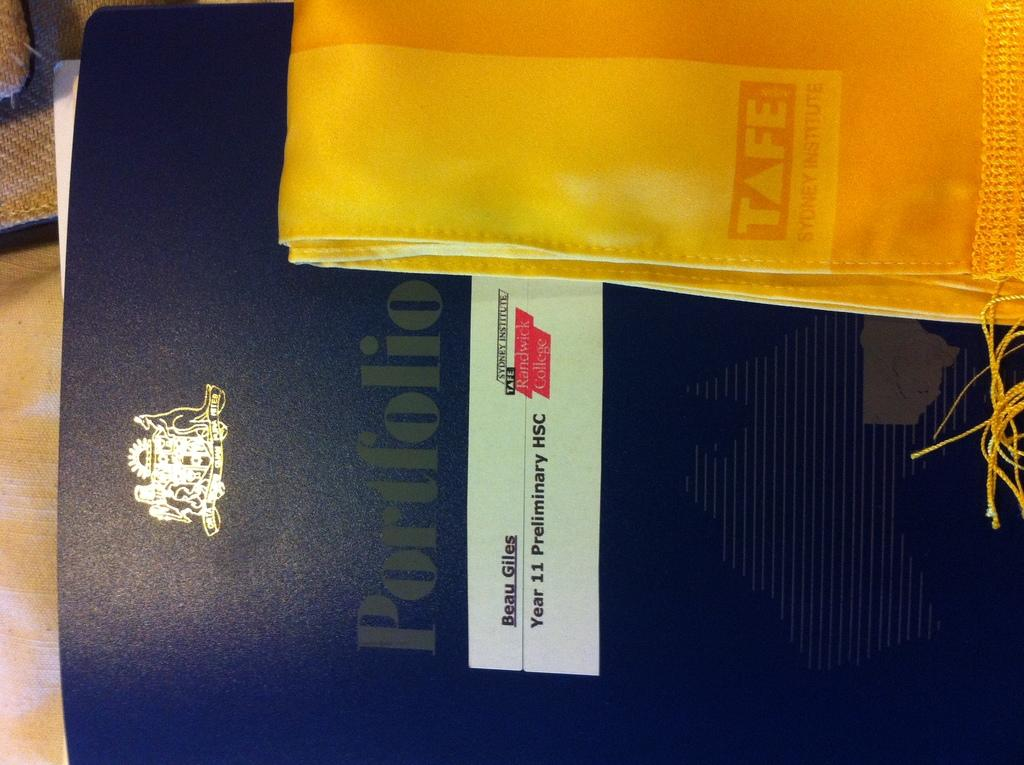What is the main subject of the image? The main subject of the image is a file cover. Is there anything placed on the file cover? Yes, there is a cloth placed on the file cover in the image. What type of brake is visible on the file cover in the image? There is no brake visible on the file cover in the image. What song is being played in the background of the image? There is no information about any song being played in the image. 